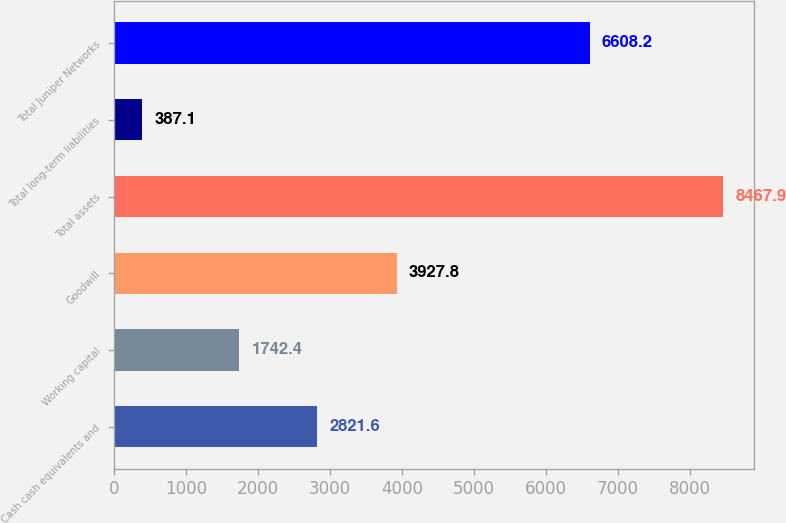<chart> <loc_0><loc_0><loc_500><loc_500><bar_chart><fcel>Cash cash equivalents and<fcel>Working capital<fcel>Goodwill<fcel>Total assets<fcel>Total long-term liabilities<fcel>Total Juniper Networks<nl><fcel>2821.6<fcel>1742.4<fcel>3927.8<fcel>8467.9<fcel>387.1<fcel>6608.2<nl></chart> 